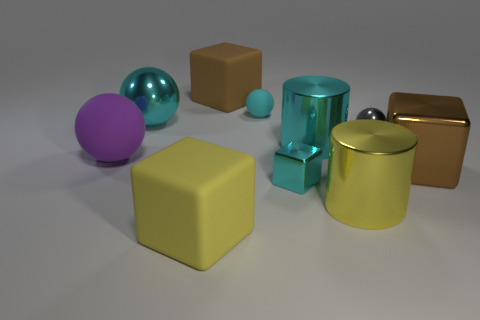Subtract all balls. How many objects are left? 6 Subtract all small cyan matte spheres. Subtract all small cyan balls. How many objects are left? 8 Add 6 cyan cubes. How many cyan cubes are left? 7 Add 6 cyan metal balls. How many cyan metal balls exist? 7 Subtract 0 gray blocks. How many objects are left? 10 